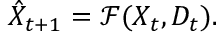Convert formula to latex. <formula><loc_0><loc_0><loc_500><loc_500>\hat { X } _ { t + 1 } = \mathcal { F } ( X _ { t } , D _ { t } ) .</formula> 